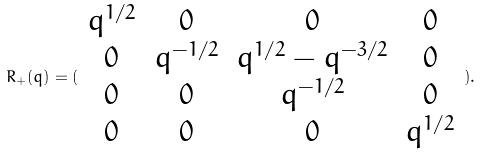Convert formula to latex. <formula><loc_0><loc_0><loc_500><loc_500>R _ { + } ( q ) = ( \begin{array} { c c c c } q ^ { 1 / 2 } & 0 & 0 & 0 \\ 0 & q ^ { - 1 / 2 } & q ^ { 1 / 2 } - q ^ { - 3 / 2 } & 0 \\ 0 & 0 & q ^ { - 1 / 2 } & 0 \\ 0 & 0 & 0 & q ^ { 1 / 2 } \end{array} ) .</formula> 